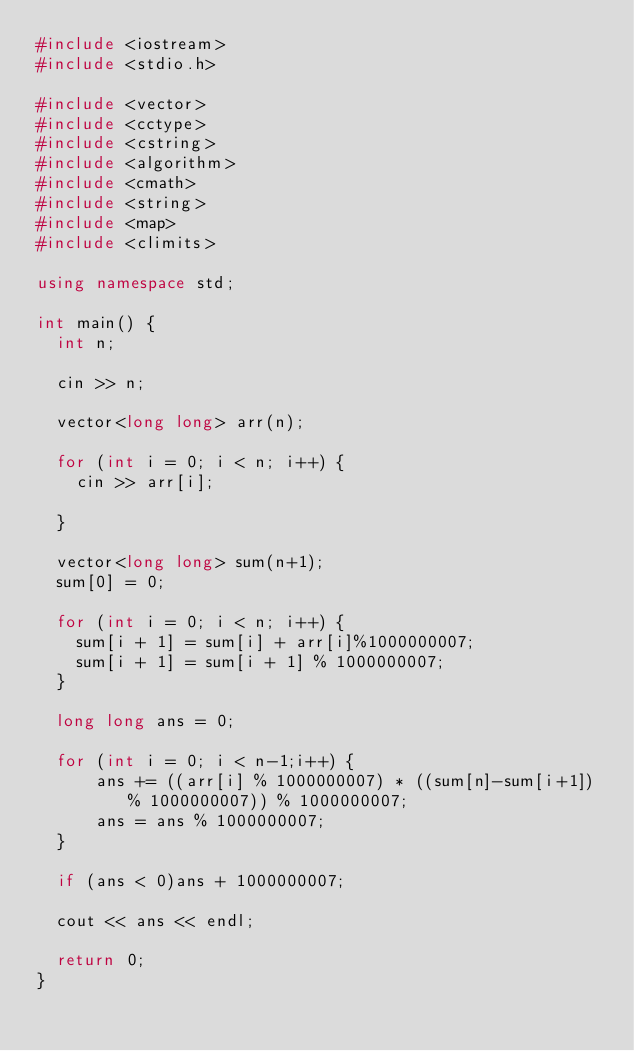<code> <loc_0><loc_0><loc_500><loc_500><_C++_>#include <iostream>
#include <stdio.h>

#include <vector>
#include <cctype>
#include <cstring>
#include <algorithm>
#include <cmath>
#include <string>
#include <map>
#include <climits>

using namespace std;

int main() {
	int n;
	
	cin >> n;

	vector<long long> arr(n);

	for (int i = 0; i < n; i++) {
		cin >> arr[i];
	
	}

	vector<long long> sum(n+1);
	sum[0] = 0;

	for (int i = 0; i < n; i++) {
		sum[i + 1] = sum[i] + arr[i]%1000000007;
		sum[i + 1] = sum[i + 1] % 1000000007;
	}
	
	long long ans = 0;
	
	for (int i = 0; i < n-1;i++) {
			ans += ((arr[i] % 1000000007) * ((sum[n]-sum[i+1]) % 1000000007)) % 1000000007;
			ans = ans % 1000000007;
	}

	if (ans < 0)ans + 1000000007;

	cout << ans << endl;

	return 0;
}</code> 